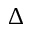<formula> <loc_0><loc_0><loc_500><loc_500>\Delta</formula> 